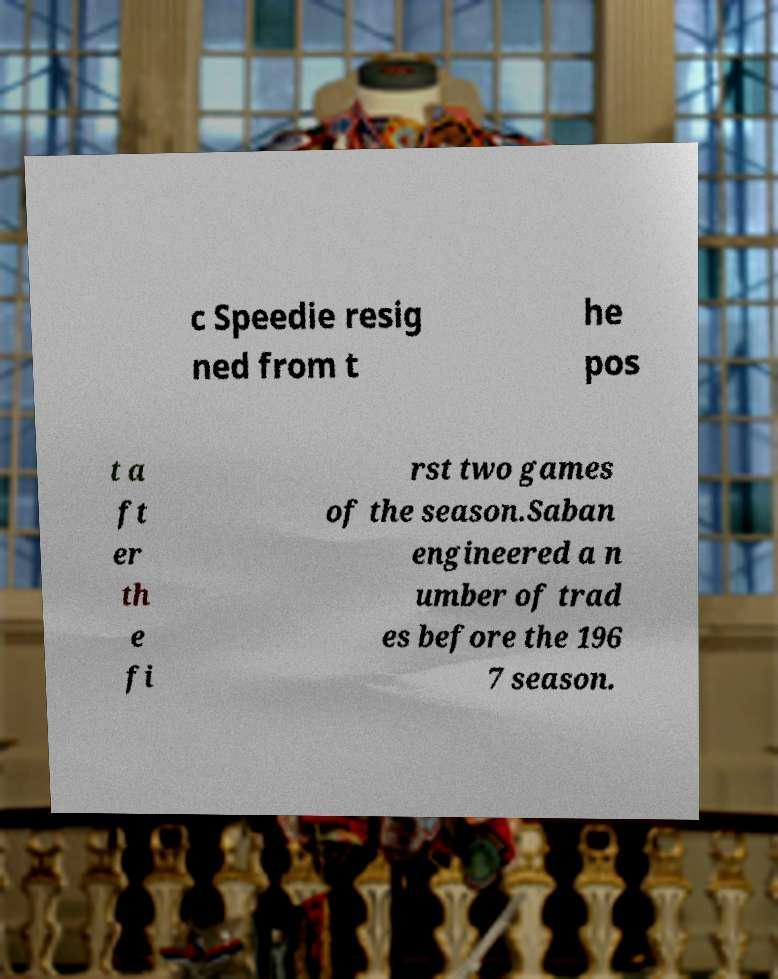Please identify and transcribe the text found in this image. c Speedie resig ned from t he pos t a ft er th e fi rst two games of the season.Saban engineered a n umber of trad es before the 196 7 season. 